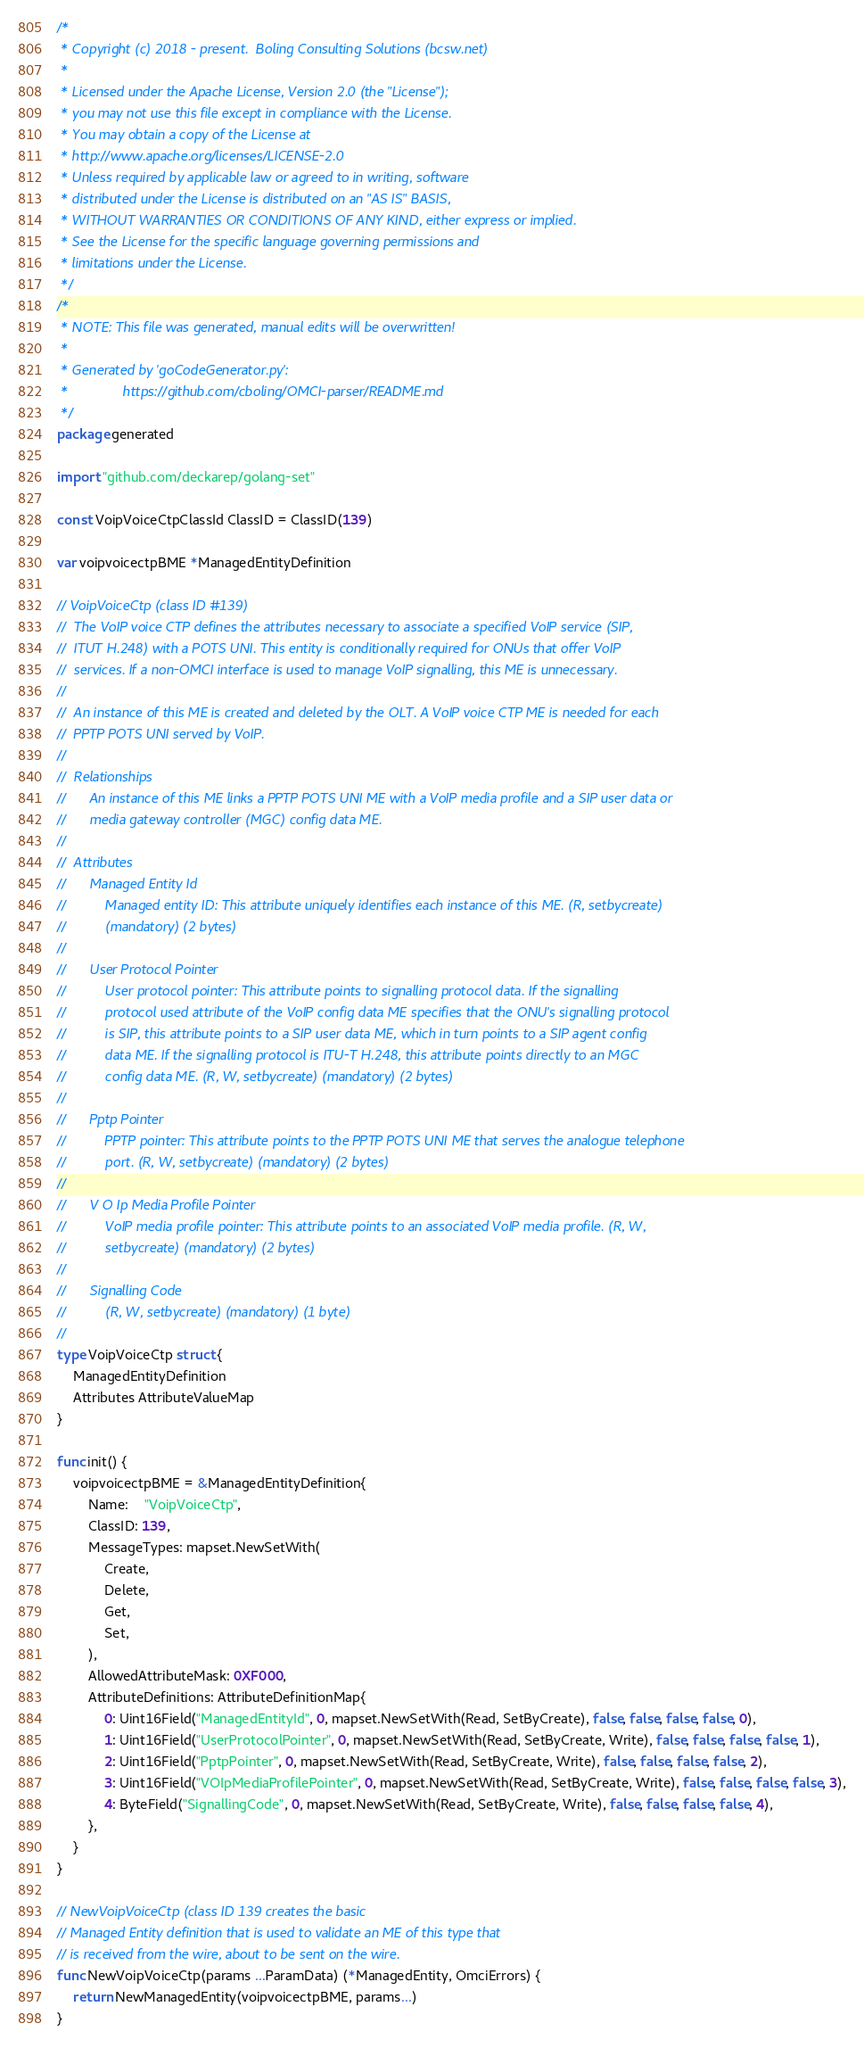Convert code to text. <code><loc_0><loc_0><loc_500><loc_500><_Go_>/*
 * Copyright (c) 2018 - present.  Boling Consulting Solutions (bcsw.net)
 *
 * Licensed under the Apache License, Version 2.0 (the "License");
 * you may not use this file except in compliance with the License.
 * You may obtain a copy of the License at
 * http://www.apache.org/licenses/LICENSE-2.0
 * Unless required by applicable law or agreed to in writing, software
 * distributed under the License is distributed on an "AS IS" BASIS,
 * WITHOUT WARRANTIES OR CONDITIONS OF ANY KIND, either express or implied.
 * See the License for the specific language governing permissions and
 * limitations under the License.
 */
/*
 * NOTE: This file was generated, manual edits will be overwritten!
 *
 * Generated by 'goCodeGenerator.py':
 *              https://github.com/cboling/OMCI-parser/README.md
 */
package generated

import "github.com/deckarep/golang-set"

const VoipVoiceCtpClassId ClassID = ClassID(139)

var voipvoicectpBME *ManagedEntityDefinition

// VoipVoiceCtp (class ID #139)
//	The VoIP voice CTP defines the attributes necessary to associate a specified VoIP service (SIP,
//	ITUT H.248) with a POTS UNI. This entity is conditionally required for ONUs that offer VoIP
//	services. If a non-OMCI interface is used to manage VoIP signalling, this ME is unnecessary.
//
//	An instance of this ME is created and deleted by the OLT. A VoIP voice CTP ME is needed for each
//	PPTP POTS UNI served by VoIP.
//
//	Relationships
//		An instance of this ME links a PPTP POTS UNI ME with a VoIP media profile and a SIP user data or
//		media gateway controller (MGC) config data ME.
//
//	Attributes
//		Managed Entity Id
//			Managed entity ID: This attribute uniquely identifies each instance of this ME. (R, setbycreate)
//			(mandatory) (2 bytes)
//
//		User Protocol Pointer
//			User protocol pointer: This attribute points to signalling protocol data. If the signalling
//			protocol used attribute of the VoIP config data ME specifies that the ONU's signalling protocol
//			is SIP, this attribute points to a SIP user data ME, which in turn points to a SIP agent config
//			data ME. If the signalling protocol is ITU-T H.248, this attribute points directly to an MGC
//			config data ME. (R, W, setbycreate) (mandatory) (2 bytes)
//
//		Pptp Pointer
//			PPTP pointer: This attribute points to the PPTP POTS UNI ME that serves the analogue telephone
//			port. (R, W, setbycreate) (mandatory) (2 bytes)
//
//		V O Ip Media Profile Pointer
//			VoIP media profile pointer: This attribute points to an associated VoIP media profile. (R, W,
//			setbycreate) (mandatory) (2 bytes)
//
//		Signalling Code
//			(R, W, setbycreate) (mandatory) (1 byte)
//
type VoipVoiceCtp struct {
	ManagedEntityDefinition
	Attributes AttributeValueMap
}

func init() {
	voipvoicectpBME = &ManagedEntityDefinition{
		Name:    "VoipVoiceCtp",
		ClassID: 139,
		MessageTypes: mapset.NewSetWith(
			Create,
			Delete,
			Get,
			Set,
		),
		AllowedAttributeMask: 0XF000,
		AttributeDefinitions: AttributeDefinitionMap{
			0: Uint16Field("ManagedEntityId", 0, mapset.NewSetWith(Read, SetByCreate), false, false, false, false, 0),
			1: Uint16Field("UserProtocolPointer", 0, mapset.NewSetWith(Read, SetByCreate, Write), false, false, false, false, 1),
			2: Uint16Field("PptpPointer", 0, mapset.NewSetWith(Read, SetByCreate, Write), false, false, false, false, 2),
			3: Uint16Field("VOIpMediaProfilePointer", 0, mapset.NewSetWith(Read, SetByCreate, Write), false, false, false, false, 3),
			4: ByteField("SignallingCode", 0, mapset.NewSetWith(Read, SetByCreate, Write), false, false, false, false, 4),
		},
	}
}

// NewVoipVoiceCtp (class ID 139 creates the basic
// Managed Entity definition that is used to validate an ME of this type that
// is received from the wire, about to be sent on the wire.
func NewVoipVoiceCtp(params ...ParamData) (*ManagedEntity, OmciErrors) {
	return NewManagedEntity(voipvoicectpBME, params...)
}
</code> 